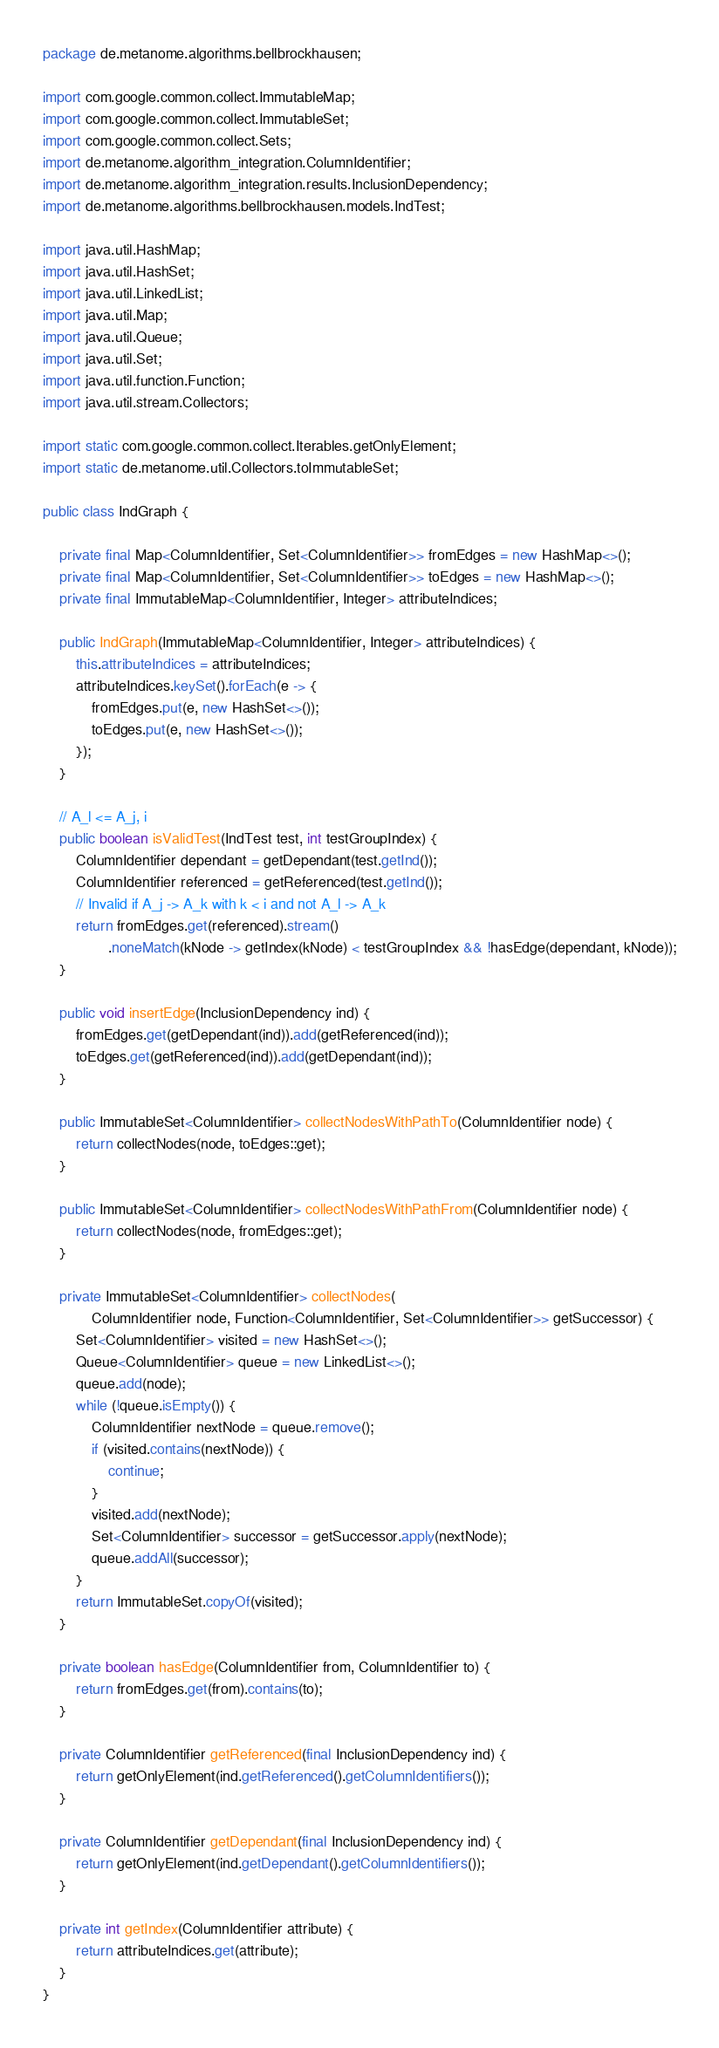<code> <loc_0><loc_0><loc_500><loc_500><_Java_>package de.metanome.algorithms.bellbrockhausen;

import com.google.common.collect.ImmutableMap;
import com.google.common.collect.ImmutableSet;
import com.google.common.collect.Sets;
import de.metanome.algorithm_integration.ColumnIdentifier;
import de.metanome.algorithm_integration.results.InclusionDependency;
import de.metanome.algorithms.bellbrockhausen.models.IndTest;

import java.util.HashMap;
import java.util.HashSet;
import java.util.LinkedList;
import java.util.Map;
import java.util.Queue;
import java.util.Set;
import java.util.function.Function;
import java.util.stream.Collectors;

import static com.google.common.collect.Iterables.getOnlyElement;
import static de.metanome.util.Collectors.toImmutableSet;

public class IndGraph {

    private final Map<ColumnIdentifier, Set<ColumnIdentifier>> fromEdges = new HashMap<>();
    private final Map<ColumnIdentifier, Set<ColumnIdentifier>> toEdges = new HashMap<>();
    private final ImmutableMap<ColumnIdentifier, Integer> attributeIndices;

    public IndGraph(ImmutableMap<ColumnIdentifier, Integer> attributeIndices) {
        this.attributeIndices = attributeIndices;
        attributeIndices.keySet().forEach(e -> {
            fromEdges.put(e, new HashSet<>());
            toEdges.put(e, new HashSet<>());
        });
    }

    // A_l <= A_j, i
    public boolean isValidTest(IndTest test, int testGroupIndex) {
        ColumnIdentifier dependant = getDependant(test.getInd());
        ColumnIdentifier referenced = getReferenced(test.getInd());
        // Invalid if A_j -> A_k with k < i and not A_l -> A_k
        return fromEdges.get(referenced).stream()
                .noneMatch(kNode -> getIndex(kNode) < testGroupIndex && !hasEdge(dependant, kNode));
    }

    public void insertEdge(InclusionDependency ind) {
        fromEdges.get(getDependant(ind)).add(getReferenced(ind));
        toEdges.get(getReferenced(ind)).add(getDependant(ind));
    }

    public ImmutableSet<ColumnIdentifier> collectNodesWithPathTo(ColumnIdentifier node) {
        return collectNodes(node, toEdges::get);
    }

    public ImmutableSet<ColumnIdentifier> collectNodesWithPathFrom(ColumnIdentifier node) {
        return collectNodes(node, fromEdges::get);
    }

    private ImmutableSet<ColumnIdentifier> collectNodes(
            ColumnIdentifier node, Function<ColumnIdentifier, Set<ColumnIdentifier>> getSuccessor) {
        Set<ColumnIdentifier> visited = new HashSet<>();
        Queue<ColumnIdentifier> queue = new LinkedList<>();
        queue.add(node);
        while (!queue.isEmpty()) {
            ColumnIdentifier nextNode = queue.remove();
            if (visited.contains(nextNode)) {
                continue;
            }
            visited.add(nextNode);
            Set<ColumnIdentifier> successor = getSuccessor.apply(nextNode);
            queue.addAll(successor);
        }
        return ImmutableSet.copyOf(visited);
    }

    private boolean hasEdge(ColumnIdentifier from, ColumnIdentifier to) {
        return fromEdges.get(from).contains(to);
    }

    private ColumnIdentifier getReferenced(final InclusionDependency ind) {
        return getOnlyElement(ind.getReferenced().getColumnIdentifiers());
    }

    private ColumnIdentifier getDependant(final InclusionDependency ind) {
        return getOnlyElement(ind.getDependant().getColumnIdentifiers());
    }

    private int getIndex(ColumnIdentifier attribute) {
        return attributeIndices.get(attribute);
    }
}
</code> 